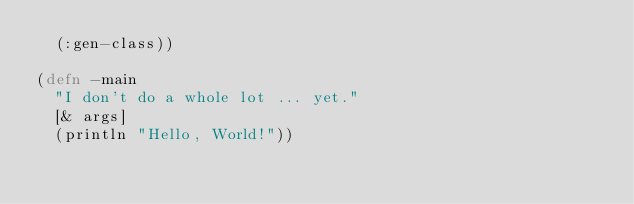<code> <loc_0><loc_0><loc_500><loc_500><_Clojure_>  (:gen-class))

(defn -main
  "I don't do a whole lot ... yet."
  [& args]
  (println "Hello, World!"))
</code> 